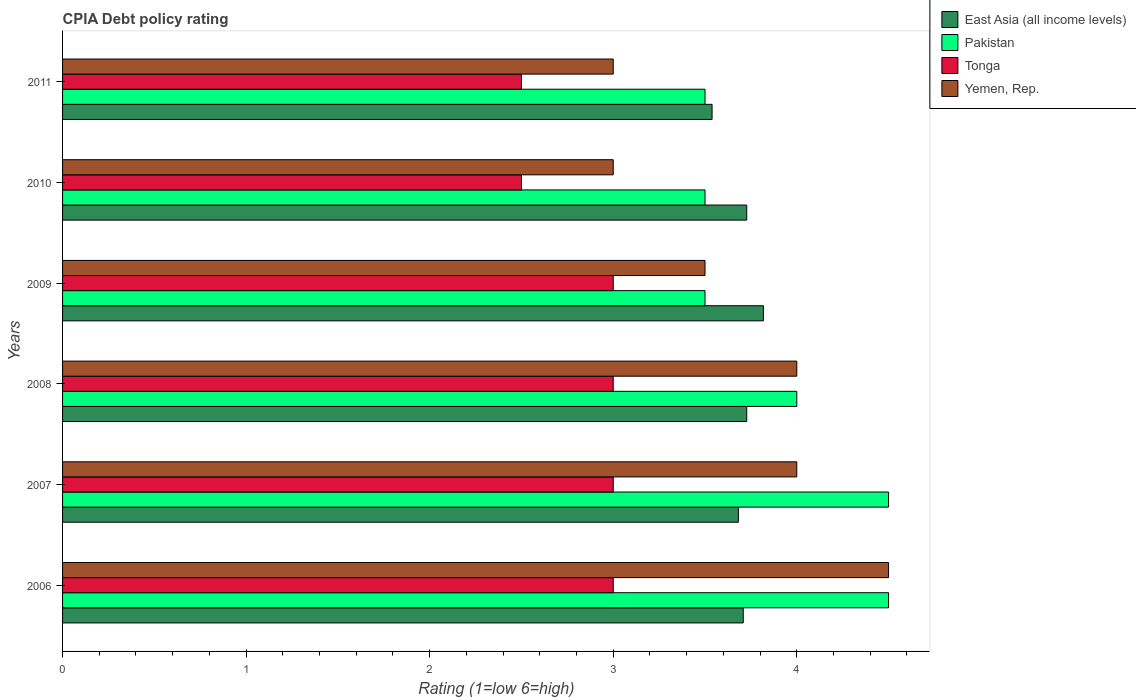How many different coloured bars are there?
Provide a succinct answer. 4. How many groups of bars are there?
Provide a short and direct response. 6. Are the number of bars per tick equal to the number of legend labels?
Ensure brevity in your answer.  Yes. How many bars are there on the 6th tick from the top?
Keep it short and to the point. 4. How many bars are there on the 5th tick from the bottom?
Provide a short and direct response. 4. What is the CPIA rating in Tonga in 2008?
Ensure brevity in your answer.  3. Across all years, what is the minimum CPIA rating in Tonga?
Give a very brief answer. 2.5. In which year was the CPIA rating in Yemen, Rep. minimum?
Your answer should be compact. 2010. What is the difference between the CPIA rating in Pakistan in 2006 and that in 2008?
Give a very brief answer. 0.5. What is the difference between the CPIA rating in Tonga in 2011 and the CPIA rating in Pakistan in 2008?
Provide a succinct answer. -1.5. What is the average CPIA rating in Tonga per year?
Your answer should be compact. 2.83. In the year 2011, what is the difference between the CPIA rating in Pakistan and CPIA rating in Yemen, Rep.?
Make the answer very short. 0.5. In how many years, is the CPIA rating in East Asia (all income levels) greater than 3.8 ?
Offer a terse response. 1. What is the ratio of the CPIA rating in Yemen, Rep. in 2008 to that in 2009?
Keep it short and to the point. 1.14. Is the CPIA rating in East Asia (all income levels) in 2006 less than that in 2007?
Your answer should be compact. No. Is the difference between the CPIA rating in Pakistan in 2008 and 2010 greater than the difference between the CPIA rating in Yemen, Rep. in 2008 and 2010?
Your answer should be very brief. No. What is the difference between the highest and the second highest CPIA rating in Pakistan?
Your response must be concise. 0. What is the difference between the highest and the lowest CPIA rating in Yemen, Rep.?
Offer a terse response. 1.5. In how many years, is the CPIA rating in East Asia (all income levels) greater than the average CPIA rating in East Asia (all income levels) taken over all years?
Offer a very short reply. 4. What does the 1st bar from the top in 2007 represents?
Offer a terse response. Yemen, Rep. What does the 3rd bar from the bottom in 2010 represents?
Your answer should be compact. Tonga. Are all the bars in the graph horizontal?
Give a very brief answer. Yes. How many years are there in the graph?
Offer a terse response. 6. What is the difference between two consecutive major ticks on the X-axis?
Provide a succinct answer. 1. Are the values on the major ticks of X-axis written in scientific E-notation?
Keep it short and to the point. No. Does the graph contain any zero values?
Keep it short and to the point. No. Does the graph contain grids?
Provide a succinct answer. No. How many legend labels are there?
Offer a very short reply. 4. What is the title of the graph?
Keep it short and to the point. CPIA Debt policy rating. What is the label or title of the X-axis?
Keep it short and to the point. Rating (1=low 6=high). What is the Rating (1=low 6=high) of East Asia (all income levels) in 2006?
Offer a terse response. 3.71. What is the Rating (1=low 6=high) of Tonga in 2006?
Keep it short and to the point. 3. What is the Rating (1=low 6=high) of Yemen, Rep. in 2006?
Give a very brief answer. 4.5. What is the Rating (1=low 6=high) in East Asia (all income levels) in 2007?
Provide a succinct answer. 3.68. What is the Rating (1=low 6=high) in Tonga in 2007?
Make the answer very short. 3. What is the Rating (1=low 6=high) of East Asia (all income levels) in 2008?
Your answer should be very brief. 3.73. What is the Rating (1=low 6=high) of Yemen, Rep. in 2008?
Offer a terse response. 4. What is the Rating (1=low 6=high) of East Asia (all income levels) in 2009?
Ensure brevity in your answer.  3.82. What is the Rating (1=low 6=high) of East Asia (all income levels) in 2010?
Make the answer very short. 3.73. What is the Rating (1=low 6=high) of East Asia (all income levels) in 2011?
Your answer should be compact. 3.54. What is the Rating (1=low 6=high) in Yemen, Rep. in 2011?
Your response must be concise. 3. Across all years, what is the maximum Rating (1=low 6=high) of East Asia (all income levels)?
Keep it short and to the point. 3.82. Across all years, what is the minimum Rating (1=low 6=high) of East Asia (all income levels)?
Make the answer very short. 3.54. Across all years, what is the minimum Rating (1=low 6=high) in Yemen, Rep.?
Keep it short and to the point. 3. What is the total Rating (1=low 6=high) in East Asia (all income levels) in the graph?
Offer a terse response. 22.2. What is the total Rating (1=low 6=high) in Pakistan in the graph?
Give a very brief answer. 23.5. What is the total Rating (1=low 6=high) in Yemen, Rep. in the graph?
Make the answer very short. 22. What is the difference between the Rating (1=low 6=high) of East Asia (all income levels) in 2006 and that in 2007?
Keep it short and to the point. 0.03. What is the difference between the Rating (1=low 6=high) of Tonga in 2006 and that in 2007?
Offer a very short reply. 0. What is the difference between the Rating (1=low 6=high) of Yemen, Rep. in 2006 and that in 2007?
Offer a very short reply. 0.5. What is the difference between the Rating (1=low 6=high) in East Asia (all income levels) in 2006 and that in 2008?
Give a very brief answer. -0.02. What is the difference between the Rating (1=low 6=high) in Pakistan in 2006 and that in 2008?
Your response must be concise. 0.5. What is the difference between the Rating (1=low 6=high) of Tonga in 2006 and that in 2008?
Offer a very short reply. 0. What is the difference between the Rating (1=low 6=high) of East Asia (all income levels) in 2006 and that in 2009?
Your answer should be compact. -0.11. What is the difference between the Rating (1=low 6=high) of Tonga in 2006 and that in 2009?
Offer a very short reply. 0. What is the difference between the Rating (1=low 6=high) of East Asia (all income levels) in 2006 and that in 2010?
Your answer should be very brief. -0.02. What is the difference between the Rating (1=low 6=high) in Pakistan in 2006 and that in 2010?
Ensure brevity in your answer.  1. What is the difference between the Rating (1=low 6=high) of Tonga in 2006 and that in 2010?
Your answer should be very brief. 0.5. What is the difference between the Rating (1=low 6=high) in East Asia (all income levels) in 2006 and that in 2011?
Your response must be concise. 0.17. What is the difference between the Rating (1=low 6=high) of Pakistan in 2006 and that in 2011?
Provide a succinct answer. 1. What is the difference between the Rating (1=low 6=high) of Tonga in 2006 and that in 2011?
Give a very brief answer. 0.5. What is the difference between the Rating (1=low 6=high) of Yemen, Rep. in 2006 and that in 2011?
Keep it short and to the point. 1.5. What is the difference between the Rating (1=low 6=high) in East Asia (all income levels) in 2007 and that in 2008?
Offer a very short reply. -0.05. What is the difference between the Rating (1=low 6=high) of Pakistan in 2007 and that in 2008?
Offer a very short reply. 0.5. What is the difference between the Rating (1=low 6=high) in Tonga in 2007 and that in 2008?
Provide a succinct answer. 0. What is the difference between the Rating (1=low 6=high) in East Asia (all income levels) in 2007 and that in 2009?
Your answer should be compact. -0.14. What is the difference between the Rating (1=low 6=high) in Yemen, Rep. in 2007 and that in 2009?
Offer a terse response. 0.5. What is the difference between the Rating (1=low 6=high) of East Asia (all income levels) in 2007 and that in 2010?
Ensure brevity in your answer.  -0.05. What is the difference between the Rating (1=low 6=high) of Pakistan in 2007 and that in 2010?
Ensure brevity in your answer.  1. What is the difference between the Rating (1=low 6=high) of Tonga in 2007 and that in 2010?
Provide a short and direct response. 0.5. What is the difference between the Rating (1=low 6=high) of Yemen, Rep. in 2007 and that in 2010?
Keep it short and to the point. 1. What is the difference between the Rating (1=low 6=high) of East Asia (all income levels) in 2007 and that in 2011?
Your answer should be very brief. 0.14. What is the difference between the Rating (1=low 6=high) in Tonga in 2007 and that in 2011?
Provide a short and direct response. 0.5. What is the difference between the Rating (1=low 6=high) of Yemen, Rep. in 2007 and that in 2011?
Offer a terse response. 1. What is the difference between the Rating (1=low 6=high) of East Asia (all income levels) in 2008 and that in 2009?
Your answer should be compact. -0.09. What is the difference between the Rating (1=low 6=high) of Yemen, Rep. in 2008 and that in 2009?
Ensure brevity in your answer.  0.5. What is the difference between the Rating (1=low 6=high) in East Asia (all income levels) in 2008 and that in 2010?
Provide a succinct answer. 0. What is the difference between the Rating (1=low 6=high) in East Asia (all income levels) in 2008 and that in 2011?
Give a very brief answer. 0.19. What is the difference between the Rating (1=low 6=high) of East Asia (all income levels) in 2009 and that in 2010?
Provide a short and direct response. 0.09. What is the difference between the Rating (1=low 6=high) in Yemen, Rep. in 2009 and that in 2010?
Your response must be concise. 0.5. What is the difference between the Rating (1=low 6=high) of East Asia (all income levels) in 2009 and that in 2011?
Keep it short and to the point. 0.28. What is the difference between the Rating (1=low 6=high) in Pakistan in 2009 and that in 2011?
Your answer should be very brief. 0. What is the difference between the Rating (1=low 6=high) in Tonga in 2009 and that in 2011?
Make the answer very short. 0.5. What is the difference between the Rating (1=low 6=high) in East Asia (all income levels) in 2010 and that in 2011?
Your answer should be very brief. 0.19. What is the difference between the Rating (1=low 6=high) in East Asia (all income levels) in 2006 and the Rating (1=low 6=high) in Pakistan in 2007?
Provide a succinct answer. -0.79. What is the difference between the Rating (1=low 6=high) of East Asia (all income levels) in 2006 and the Rating (1=low 6=high) of Tonga in 2007?
Ensure brevity in your answer.  0.71. What is the difference between the Rating (1=low 6=high) of East Asia (all income levels) in 2006 and the Rating (1=low 6=high) of Yemen, Rep. in 2007?
Make the answer very short. -0.29. What is the difference between the Rating (1=low 6=high) of Pakistan in 2006 and the Rating (1=low 6=high) of Tonga in 2007?
Offer a terse response. 1.5. What is the difference between the Rating (1=low 6=high) of Pakistan in 2006 and the Rating (1=low 6=high) of Yemen, Rep. in 2007?
Keep it short and to the point. 0.5. What is the difference between the Rating (1=low 6=high) of Tonga in 2006 and the Rating (1=low 6=high) of Yemen, Rep. in 2007?
Offer a very short reply. -1. What is the difference between the Rating (1=low 6=high) in East Asia (all income levels) in 2006 and the Rating (1=low 6=high) in Pakistan in 2008?
Provide a short and direct response. -0.29. What is the difference between the Rating (1=low 6=high) in East Asia (all income levels) in 2006 and the Rating (1=low 6=high) in Tonga in 2008?
Your response must be concise. 0.71. What is the difference between the Rating (1=low 6=high) in East Asia (all income levels) in 2006 and the Rating (1=low 6=high) in Yemen, Rep. in 2008?
Keep it short and to the point. -0.29. What is the difference between the Rating (1=low 6=high) of Pakistan in 2006 and the Rating (1=low 6=high) of Tonga in 2008?
Provide a succinct answer. 1.5. What is the difference between the Rating (1=low 6=high) in East Asia (all income levels) in 2006 and the Rating (1=low 6=high) in Pakistan in 2009?
Your answer should be very brief. 0.21. What is the difference between the Rating (1=low 6=high) in East Asia (all income levels) in 2006 and the Rating (1=low 6=high) in Tonga in 2009?
Give a very brief answer. 0.71. What is the difference between the Rating (1=low 6=high) in East Asia (all income levels) in 2006 and the Rating (1=low 6=high) in Yemen, Rep. in 2009?
Provide a short and direct response. 0.21. What is the difference between the Rating (1=low 6=high) of Pakistan in 2006 and the Rating (1=low 6=high) of Tonga in 2009?
Make the answer very short. 1.5. What is the difference between the Rating (1=low 6=high) of East Asia (all income levels) in 2006 and the Rating (1=low 6=high) of Pakistan in 2010?
Offer a very short reply. 0.21. What is the difference between the Rating (1=low 6=high) in East Asia (all income levels) in 2006 and the Rating (1=low 6=high) in Tonga in 2010?
Make the answer very short. 1.21. What is the difference between the Rating (1=low 6=high) in East Asia (all income levels) in 2006 and the Rating (1=low 6=high) in Yemen, Rep. in 2010?
Provide a short and direct response. 0.71. What is the difference between the Rating (1=low 6=high) of Pakistan in 2006 and the Rating (1=low 6=high) of Tonga in 2010?
Offer a very short reply. 2. What is the difference between the Rating (1=low 6=high) in Pakistan in 2006 and the Rating (1=low 6=high) in Yemen, Rep. in 2010?
Your answer should be very brief. 1.5. What is the difference between the Rating (1=low 6=high) of Tonga in 2006 and the Rating (1=low 6=high) of Yemen, Rep. in 2010?
Keep it short and to the point. 0. What is the difference between the Rating (1=low 6=high) in East Asia (all income levels) in 2006 and the Rating (1=low 6=high) in Pakistan in 2011?
Offer a very short reply. 0.21. What is the difference between the Rating (1=low 6=high) of East Asia (all income levels) in 2006 and the Rating (1=low 6=high) of Tonga in 2011?
Offer a very short reply. 1.21. What is the difference between the Rating (1=low 6=high) of East Asia (all income levels) in 2006 and the Rating (1=low 6=high) of Yemen, Rep. in 2011?
Give a very brief answer. 0.71. What is the difference between the Rating (1=low 6=high) in Pakistan in 2006 and the Rating (1=low 6=high) in Tonga in 2011?
Provide a short and direct response. 2. What is the difference between the Rating (1=low 6=high) in Pakistan in 2006 and the Rating (1=low 6=high) in Yemen, Rep. in 2011?
Give a very brief answer. 1.5. What is the difference between the Rating (1=low 6=high) in Tonga in 2006 and the Rating (1=low 6=high) in Yemen, Rep. in 2011?
Provide a short and direct response. 0. What is the difference between the Rating (1=low 6=high) of East Asia (all income levels) in 2007 and the Rating (1=low 6=high) of Pakistan in 2008?
Give a very brief answer. -0.32. What is the difference between the Rating (1=low 6=high) of East Asia (all income levels) in 2007 and the Rating (1=low 6=high) of Tonga in 2008?
Provide a succinct answer. 0.68. What is the difference between the Rating (1=low 6=high) of East Asia (all income levels) in 2007 and the Rating (1=low 6=high) of Yemen, Rep. in 2008?
Provide a succinct answer. -0.32. What is the difference between the Rating (1=low 6=high) of Pakistan in 2007 and the Rating (1=low 6=high) of Tonga in 2008?
Your response must be concise. 1.5. What is the difference between the Rating (1=low 6=high) in Pakistan in 2007 and the Rating (1=low 6=high) in Yemen, Rep. in 2008?
Your answer should be very brief. 0.5. What is the difference between the Rating (1=low 6=high) in East Asia (all income levels) in 2007 and the Rating (1=low 6=high) in Pakistan in 2009?
Offer a terse response. 0.18. What is the difference between the Rating (1=low 6=high) of East Asia (all income levels) in 2007 and the Rating (1=low 6=high) of Tonga in 2009?
Keep it short and to the point. 0.68. What is the difference between the Rating (1=low 6=high) in East Asia (all income levels) in 2007 and the Rating (1=low 6=high) in Yemen, Rep. in 2009?
Offer a terse response. 0.18. What is the difference between the Rating (1=low 6=high) in Pakistan in 2007 and the Rating (1=low 6=high) in Yemen, Rep. in 2009?
Make the answer very short. 1. What is the difference between the Rating (1=low 6=high) in East Asia (all income levels) in 2007 and the Rating (1=low 6=high) in Pakistan in 2010?
Provide a succinct answer. 0.18. What is the difference between the Rating (1=low 6=high) of East Asia (all income levels) in 2007 and the Rating (1=low 6=high) of Tonga in 2010?
Make the answer very short. 1.18. What is the difference between the Rating (1=low 6=high) in East Asia (all income levels) in 2007 and the Rating (1=low 6=high) in Yemen, Rep. in 2010?
Ensure brevity in your answer.  0.68. What is the difference between the Rating (1=low 6=high) in Tonga in 2007 and the Rating (1=low 6=high) in Yemen, Rep. in 2010?
Ensure brevity in your answer.  0. What is the difference between the Rating (1=low 6=high) of East Asia (all income levels) in 2007 and the Rating (1=low 6=high) of Pakistan in 2011?
Keep it short and to the point. 0.18. What is the difference between the Rating (1=low 6=high) in East Asia (all income levels) in 2007 and the Rating (1=low 6=high) in Tonga in 2011?
Your answer should be compact. 1.18. What is the difference between the Rating (1=low 6=high) in East Asia (all income levels) in 2007 and the Rating (1=low 6=high) in Yemen, Rep. in 2011?
Make the answer very short. 0.68. What is the difference between the Rating (1=low 6=high) of Pakistan in 2007 and the Rating (1=low 6=high) of Tonga in 2011?
Ensure brevity in your answer.  2. What is the difference between the Rating (1=low 6=high) of Tonga in 2007 and the Rating (1=low 6=high) of Yemen, Rep. in 2011?
Provide a short and direct response. 0. What is the difference between the Rating (1=low 6=high) of East Asia (all income levels) in 2008 and the Rating (1=low 6=high) of Pakistan in 2009?
Ensure brevity in your answer.  0.23. What is the difference between the Rating (1=low 6=high) in East Asia (all income levels) in 2008 and the Rating (1=low 6=high) in Tonga in 2009?
Make the answer very short. 0.73. What is the difference between the Rating (1=low 6=high) in East Asia (all income levels) in 2008 and the Rating (1=low 6=high) in Yemen, Rep. in 2009?
Your response must be concise. 0.23. What is the difference between the Rating (1=low 6=high) in Pakistan in 2008 and the Rating (1=low 6=high) in Tonga in 2009?
Offer a very short reply. 1. What is the difference between the Rating (1=low 6=high) of Pakistan in 2008 and the Rating (1=low 6=high) of Yemen, Rep. in 2009?
Provide a short and direct response. 0.5. What is the difference between the Rating (1=low 6=high) of East Asia (all income levels) in 2008 and the Rating (1=low 6=high) of Pakistan in 2010?
Provide a short and direct response. 0.23. What is the difference between the Rating (1=low 6=high) in East Asia (all income levels) in 2008 and the Rating (1=low 6=high) in Tonga in 2010?
Offer a very short reply. 1.23. What is the difference between the Rating (1=low 6=high) of East Asia (all income levels) in 2008 and the Rating (1=low 6=high) of Yemen, Rep. in 2010?
Your answer should be very brief. 0.73. What is the difference between the Rating (1=low 6=high) of Pakistan in 2008 and the Rating (1=low 6=high) of Yemen, Rep. in 2010?
Your response must be concise. 1. What is the difference between the Rating (1=low 6=high) in Tonga in 2008 and the Rating (1=low 6=high) in Yemen, Rep. in 2010?
Offer a very short reply. 0. What is the difference between the Rating (1=low 6=high) of East Asia (all income levels) in 2008 and the Rating (1=low 6=high) of Pakistan in 2011?
Give a very brief answer. 0.23. What is the difference between the Rating (1=low 6=high) in East Asia (all income levels) in 2008 and the Rating (1=low 6=high) in Tonga in 2011?
Your answer should be very brief. 1.23. What is the difference between the Rating (1=low 6=high) in East Asia (all income levels) in 2008 and the Rating (1=low 6=high) in Yemen, Rep. in 2011?
Ensure brevity in your answer.  0.73. What is the difference between the Rating (1=low 6=high) of Pakistan in 2008 and the Rating (1=low 6=high) of Yemen, Rep. in 2011?
Ensure brevity in your answer.  1. What is the difference between the Rating (1=low 6=high) in East Asia (all income levels) in 2009 and the Rating (1=low 6=high) in Pakistan in 2010?
Your answer should be compact. 0.32. What is the difference between the Rating (1=low 6=high) in East Asia (all income levels) in 2009 and the Rating (1=low 6=high) in Tonga in 2010?
Provide a succinct answer. 1.32. What is the difference between the Rating (1=low 6=high) in East Asia (all income levels) in 2009 and the Rating (1=low 6=high) in Yemen, Rep. in 2010?
Offer a very short reply. 0.82. What is the difference between the Rating (1=low 6=high) in Pakistan in 2009 and the Rating (1=low 6=high) in Tonga in 2010?
Provide a succinct answer. 1. What is the difference between the Rating (1=low 6=high) in Tonga in 2009 and the Rating (1=low 6=high) in Yemen, Rep. in 2010?
Keep it short and to the point. 0. What is the difference between the Rating (1=low 6=high) in East Asia (all income levels) in 2009 and the Rating (1=low 6=high) in Pakistan in 2011?
Keep it short and to the point. 0.32. What is the difference between the Rating (1=low 6=high) in East Asia (all income levels) in 2009 and the Rating (1=low 6=high) in Tonga in 2011?
Offer a terse response. 1.32. What is the difference between the Rating (1=low 6=high) of East Asia (all income levels) in 2009 and the Rating (1=low 6=high) of Yemen, Rep. in 2011?
Offer a very short reply. 0.82. What is the difference between the Rating (1=low 6=high) in Pakistan in 2009 and the Rating (1=low 6=high) in Yemen, Rep. in 2011?
Provide a short and direct response. 0.5. What is the difference between the Rating (1=low 6=high) in Tonga in 2009 and the Rating (1=low 6=high) in Yemen, Rep. in 2011?
Your answer should be very brief. 0. What is the difference between the Rating (1=low 6=high) in East Asia (all income levels) in 2010 and the Rating (1=low 6=high) in Pakistan in 2011?
Offer a terse response. 0.23. What is the difference between the Rating (1=low 6=high) in East Asia (all income levels) in 2010 and the Rating (1=low 6=high) in Tonga in 2011?
Your response must be concise. 1.23. What is the difference between the Rating (1=low 6=high) of East Asia (all income levels) in 2010 and the Rating (1=low 6=high) of Yemen, Rep. in 2011?
Ensure brevity in your answer.  0.73. What is the difference between the Rating (1=low 6=high) of Tonga in 2010 and the Rating (1=low 6=high) of Yemen, Rep. in 2011?
Make the answer very short. -0.5. What is the average Rating (1=low 6=high) in East Asia (all income levels) per year?
Keep it short and to the point. 3.7. What is the average Rating (1=low 6=high) of Pakistan per year?
Ensure brevity in your answer.  3.92. What is the average Rating (1=low 6=high) of Tonga per year?
Your response must be concise. 2.83. What is the average Rating (1=low 6=high) of Yemen, Rep. per year?
Your answer should be compact. 3.67. In the year 2006, what is the difference between the Rating (1=low 6=high) in East Asia (all income levels) and Rating (1=low 6=high) in Pakistan?
Keep it short and to the point. -0.79. In the year 2006, what is the difference between the Rating (1=low 6=high) of East Asia (all income levels) and Rating (1=low 6=high) of Tonga?
Your answer should be very brief. 0.71. In the year 2006, what is the difference between the Rating (1=low 6=high) of East Asia (all income levels) and Rating (1=low 6=high) of Yemen, Rep.?
Your answer should be compact. -0.79. In the year 2006, what is the difference between the Rating (1=low 6=high) of Pakistan and Rating (1=low 6=high) of Tonga?
Provide a succinct answer. 1.5. In the year 2006, what is the difference between the Rating (1=low 6=high) in Pakistan and Rating (1=low 6=high) in Yemen, Rep.?
Keep it short and to the point. 0. In the year 2006, what is the difference between the Rating (1=low 6=high) in Tonga and Rating (1=low 6=high) in Yemen, Rep.?
Give a very brief answer. -1.5. In the year 2007, what is the difference between the Rating (1=low 6=high) in East Asia (all income levels) and Rating (1=low 6=high) in Pakistan?
Provide a succinct answer. -0.82. In the year 2007, what is the difference between the Rating (1=low 6=high) of East Asia (all income levels) and Rating (1=low 6=high) of Tonga?
Ensure brevity in your answer.  0.68. In the year 2007, what is the difference between the Rating (1=low 6=high) of East Asia (all income levels) and Rating (1=low 6=high) of Yemen, Rep.?
Provide a short and direct response. -0.32. In the year 2007, what is the difference between the Rating (1=low 6=high) in Pakistan and Rating (1=low 6=high) in Tonga?
Ensure brevity in your answer.  1.5. In the year 2008, what is the difference between the Rating (1=low 6=high) in East Asia (all income levels) and Rating (1=low 6=high) in Pakistan?
Your response must be concise. -0.27. In the year 2008, what is the difference between the Rating (1=low 6=high) in East Asia (all income levels) and Rating (1=low 6=high) in Tonga?
Ensure brevity in your answer.  0.73. In the year 2008, what is the difference between the Rating (1=low 6=high) in East Asia (all income levels) and Rating (1=low 6=high) in Yemen, Rep.?
Your answer should be compact. -0.27. In the year 2009, what is the difference between the Rating (1=low 6=high) of East Asia (all income levels) and Rating (1=low 6=high) of Pakistan?
Your response must be concise. 0.32. In the year 2009, what is the difference between the Rating (1=low 6=high) of East Asia (all income levels) and Rating (1=low 6=high) of Tonga?
Make the answer very short. 0.82. In the year 2009, what is the difference between the Rating (1=low 6=high) of East Asia (all income levels) and Rating (1=low 6=high) of Yemen, Rep.?
Offer a terse response. 0.32. In the year 2009, what is the difference between the Rating (1=low 6=high) of Pakistan and Rating (1=low 6=high) of Yemen, Rep.?
Your response must be concise. 0. In the year 2010, what is the difference between the Rating (1=low 6=high) in East Asia (all income levels) and Rating (1=low 6=high) in Pakistan?
Keep it short and to the point. 0.23. In the year 2010, what is the difference between the Rating (1=low 6=high) of East Asia (all income levels) and Rating (1=low 6=high) of Tonga?
Your answer should be compact. 1.23. In the year 2010, what is the difference between the Rating (1=low 6=high) of East Asia (all income levels) and Rating (1=low 6=high) of Yemen, Rep.?
Your answer should be compact. 0.73. In the year 2011, what is the difference between the Rating (1=low 6=high) of East Asia (all income levels) and Rating (1=low 6=high) of Pakistan?
Your answer should be compact. 0.04. In the year 2011, what is the difference between the Rating (1=low 6=high) in East Asia (all income levels) and Rating (1=low 6=high) in Tonga?
Provide a short and direct response. 1.04. In the year 2011, what is the difference between the Rating (1=low 6=high) in East Asia (all income levels) and Rating (1=low 6=high) in Yemen, Rep.?
Your response must be concise. 0.54. In the year 2011, what is the difference between the Rating (1=low 6=high) in Pakistan and Rating (1=low 6=high) in Tonga?
Your answer should be compact. 1. In the year 2011, what is the difference between the Rating (1=low 6=high) in Tonga and Rating (1=low 6=high) in Yemen, Rep.?
Ensure brevity in your answer.  -0.5. What is the ratio of the Rating (1=low 6=high) in Pakistan in 2006 to that in 2007?
Offer a terse response. 1. What is the ratio of the Rating (1=low 6=high) of Tonga in 2006 to that in 2007?
Provide a short and direct response. 1. What is the ratio of the Rating (1=low 6=high) in Yemen, Rep. in 2006 to that in 2007?
Your answer should be very brief. 1.12. What is the ratio of the Rating (1=low 6=high) in East Asia (all income levels) in 2006 to that in 2009?
Your answer should be very brief. 0.97. What is the ratio of the Rating (1=low 6=high) of Pakistan in 2006 to that in 2009?
Your answer should be very brief. 1.29. What is the ratio of the Rating (1=low 6=high) in Yemen, Rep. in 2006 to that in 2009?
Your answer should be very brief. 1.29. What is the ratio of the Rating (1=low 6=high) in East Asia (all income levels) in 2006 to that in 2010?
Make the answer very short. 0.99. What is the ratio of the Rating (1=low 6=high) of Pakistan in 2006 to that in 2010?
Make the answer very short. 1.29. What is the ratio of the Rating (1=low 6=high) in Tonga in 2006 to that in 2010?
Give a very brief answer. 1.2. What is the ratio of the Rating (1=low 6=high) in Yemen, Rep. in 2006 to that in 2010?
Offer a very short reply. 1.5. What is the ratio of the Rating (1=low 6=high) of East Asia (all income levels) in 2006 to that in 2011?
Give a very brief answer. 1.05. What is the ratio of the Rating (1=low 6=high) in Tonga in 2006 to that in 2011?
Give a very brief answer. 1.2. What is the ratio of the Rating (1=low 6=high) of East Asia (all income levels) in 2007 to that in 2008?
Ensure brevity in your answer.  0.99. What is the ratio of the Rating (1=low 6=high) in Tonga in 2007 to that in 2008?
Offer a very short reply. 1. What is the ratio of the Rating (1=low 6=high) in Yemen, Rep. in 2007 to that in 2008?
Provide a succinct answer. 1. What is the ratio of the Rating (1=low 6=high) of Tonga in 2007 to that in 2009?
Keep it short and to the point. 1. What is the ratio of the Rating (1=low 6=high) of East Asia (all income levels) in 2007 to that in 2010?
Your answer should be very brief. 0.99. What is the ratio of the Rating (1=low 6=high) in Pakistan in 2007 to that in 2010?
Ensure brevity in your answer.  1.29. What is the ratio of the Rating (1=low 6=high) in East Asia (all income levels) in 2007 to that in 2011?
Your answer should be compact. 1.04. What is the ratio of the Rating (1=low 6=high) of East Asia (all income levels) in 2008 to that in 2009?
Ensure brevity in your answer.  0.98. What is the ratio of the Rating (1=low 6=high) of Yemen, Rep. in 2008 to that in 2009?
Give a very brief answer. 1.14. What is the ratio of the Rating (1=low 6=high) of East Asia (all income levels) in 2008 to that in 2010?
Provide a succinct answer. 1. What is the ratio of the Rating (1=low 6=high) in Pakistan in 2008 to that in 2010?
Provide a succinct answer. 1.14. What is the ratio of the Rating (1=low 6=high) of Tonga in 2008 to that in 2010?
Ensure brevity in your answer.  1.2. What is the ratio of the Rating (1=low 6=high) of Yemen, Rep. in 2008 to that in 2010?
Your answer should be very brief. 1.33. What is the ratio of the Rating (1=low 6=high) of East Asia (all income levels) in 2008 to that in 2011?
Your answer should be very brief. 1.05. What is the ratio of the Rating (1=low 6=high) in Yemen, Rep. in 2008 to that in 2011?
Your response must be concise. 1.33. What is the ratio of the Rating (1=low 6=high) of East Asia (all income levels) in 2009 to that in 2010?
Your answer should be compact. 1.02. What is the ratio of the Rating (1=low 6=high) in East Asia (all income levels) in 2009 to that in 2011?
Ensure brevity in your answer.  1.08. What is the ratio of the Rating (1=low 6=high) in Yemen, Rep. in 2009 to that in 2011?
Your response must be concise. 1.17. What is the ratio of the Rating (1=low 6=high) of East Asia (all income levels) in 2010 to that in 2011?
Your answer should be very brief. 1.05. What is the difference between the highest and the second highest Rating (1=low 6=high) of East Asia (all income levels)?
Offer a very short reply. 0.09. What is the difference between the highest and the lowest Rating (1=low 6=high) in East Asia (all income levels)?
Give a very brief answer. 0.28. What is the difference between the highest and the lowest Rating (1=low 6=high) of Tonga?
Your answer should be compact. 0.5. What is the difference between the highest and the lowest Rating (1=low 6=high) in Yemen, Rep.?
Your answer should be compact. 1.5. 